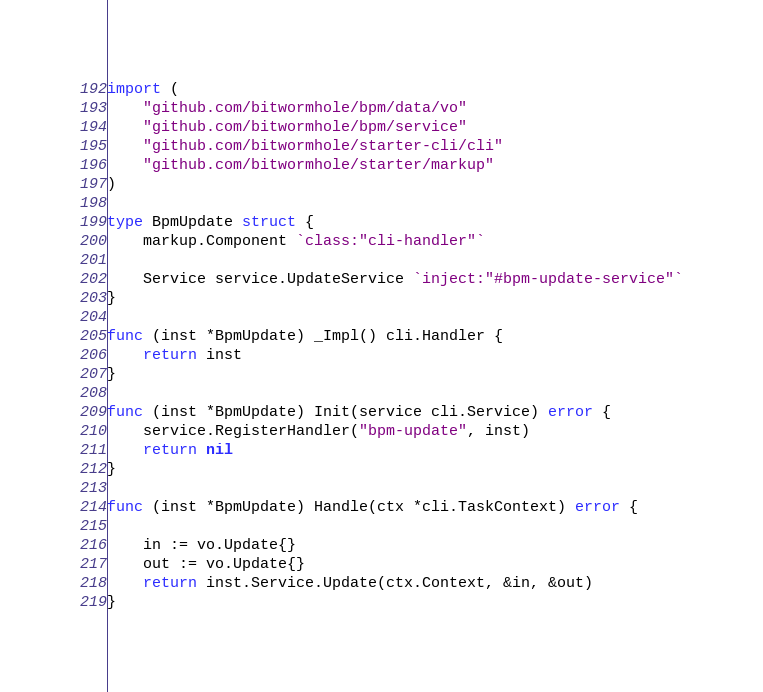<code> <loc_0><loc_0><loc_500><loc_500><_Go_>
import (
	"github.com/bitwormhole/bpm/data/vo"
	"github.com/bitwormhole/bpm/service"
	"github.com/bitwormhole/starter-cli/cli"
	"github.com/bitwormhole/starter/markup"
)

type BpmUpdate struct {
	markup.Component `class:"cli-handler"`

	Service service.UpdateService `inject:"#bpm-update-service"`
}

func (inst *BpmUpdate) _Impl() cli.Handler {
	return inst
}

func (inst *BpmUpdate) Init(service cli.Service) error {
	service.RegisterHandler("bpm-update", inst)
	return nil
}

func (inst *BpmUpdate) Handle(ctx *cli.TaskContext) error {

	in := vo.Update{}
	out := vo.Update{}
	return inst.Service.Update(ctx.Context, &in, &out)
}
</code> 